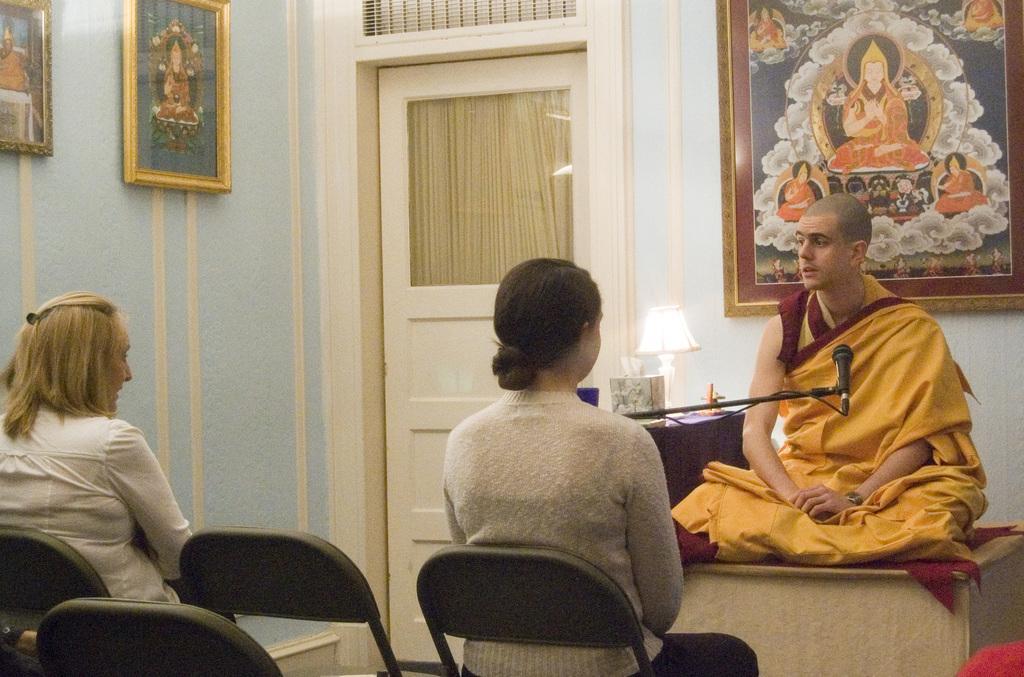Could you give a brief overview of what you see in this image? people are sitting on the black chairs in a room. in the front of them a person is sitting on a table wearing a yellow dress. in front of him there is a microphone. and at the left of him there is a lamp. behind him there is a photo frame on the wall and a white door. at the left wall there is blue paint and 2 photo frames are present. 